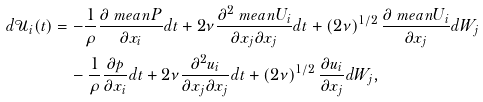Convert formula to latex. <formula><loc_0><loc_0><loc_500><loc_500>d \mathcal { U } _ { i } ( t ) & = - \frac { 1 } { \rho } \frac { \partial \ m e a n { P } } { \partial x _ { i } } d t + 2 \nu \frac { \partial ^ { 2 } \ m e a n { U _ { i } } } { \partial x _ { j } \partial x _ { j } } d t + \left ( 2 \nu \right ) ^ { 1 / 2 } \frac { \partial \ m e a n { U _ { i } } } { \partial x _ { j } } d W _ { j } \\ & \quad - \frac { 1 } { \rho } \frac { \partial p } { \partial x _ { i } } d t + 2 \nu \frac { \partial ^ { 2 } u _ { i } } { \partial x _ { j } \partial x _ { j } } d t + \left ( 2 \nu \right ) ^ { 1 / 2 } \frac { \partial u _ { i } } { \partial x _ { j } } d W _ { j } ,</formula> 